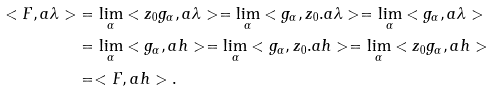Convert formula to latex. <formula><loc_0><loc_0><loc_500><loc_500>< F , a \lambda > & = \lim _ { \alpha } < z _ { 0 } g _ { \alpha } , a \lambda > = \lim _ { \alpha } < g _ { \alpha } , z _ { 0 } . a \lambda > = \lim _ { \alpha } < g _ { \alpha } , a \lambda > \\ & = \lim _ { \alpha } < g _ { \alpha } , a h > = \lim _ { \alpha } < g _ { \alpha } , z _ { 0 } . a h > = \lim _ { \alpha } < z _ { 0 } g _ { \alpha } , a h > \\ & = < F , a h > .</formula> 